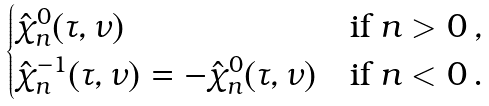<formula> <loc_0><loc_0><loc_500><loc_500>\begin{cases} \hat { \chi } ^ { 0 } _ { n } ( \tau , \nu ) & \text {if $n > 0$} \, , \\ \hat { \chi } ^ { - 1 } _ { n } ( \tau , \nu ) = - \hat { \chi } ^ { 0 } _ { n } ( \tau , \nu ) & \text {if $n < 0$} \, . \end{cases}</formula> 